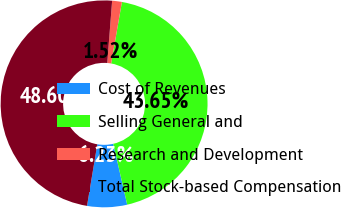Convert chart. <chart><loc_0><loc_0><loc_500><loc_500><pie_chart><fcel>Cost of Revenues<fcel>Selling General and<fcel>Research and Development<fcel>Total Stock-based Compensation<nl><fcel>6.23%<fcel>43.65%<fcel>1.52%<fcel>48.6%<nl></chart> 